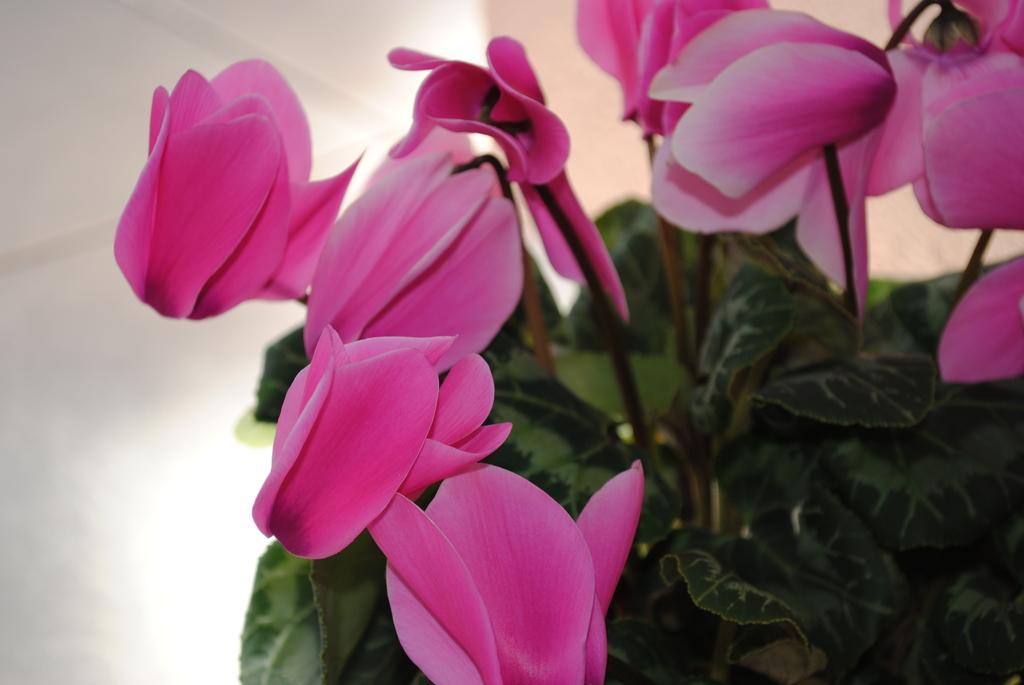How would you summarize this image in a sentence or two? In this image I can see flowers which are pink in color. 